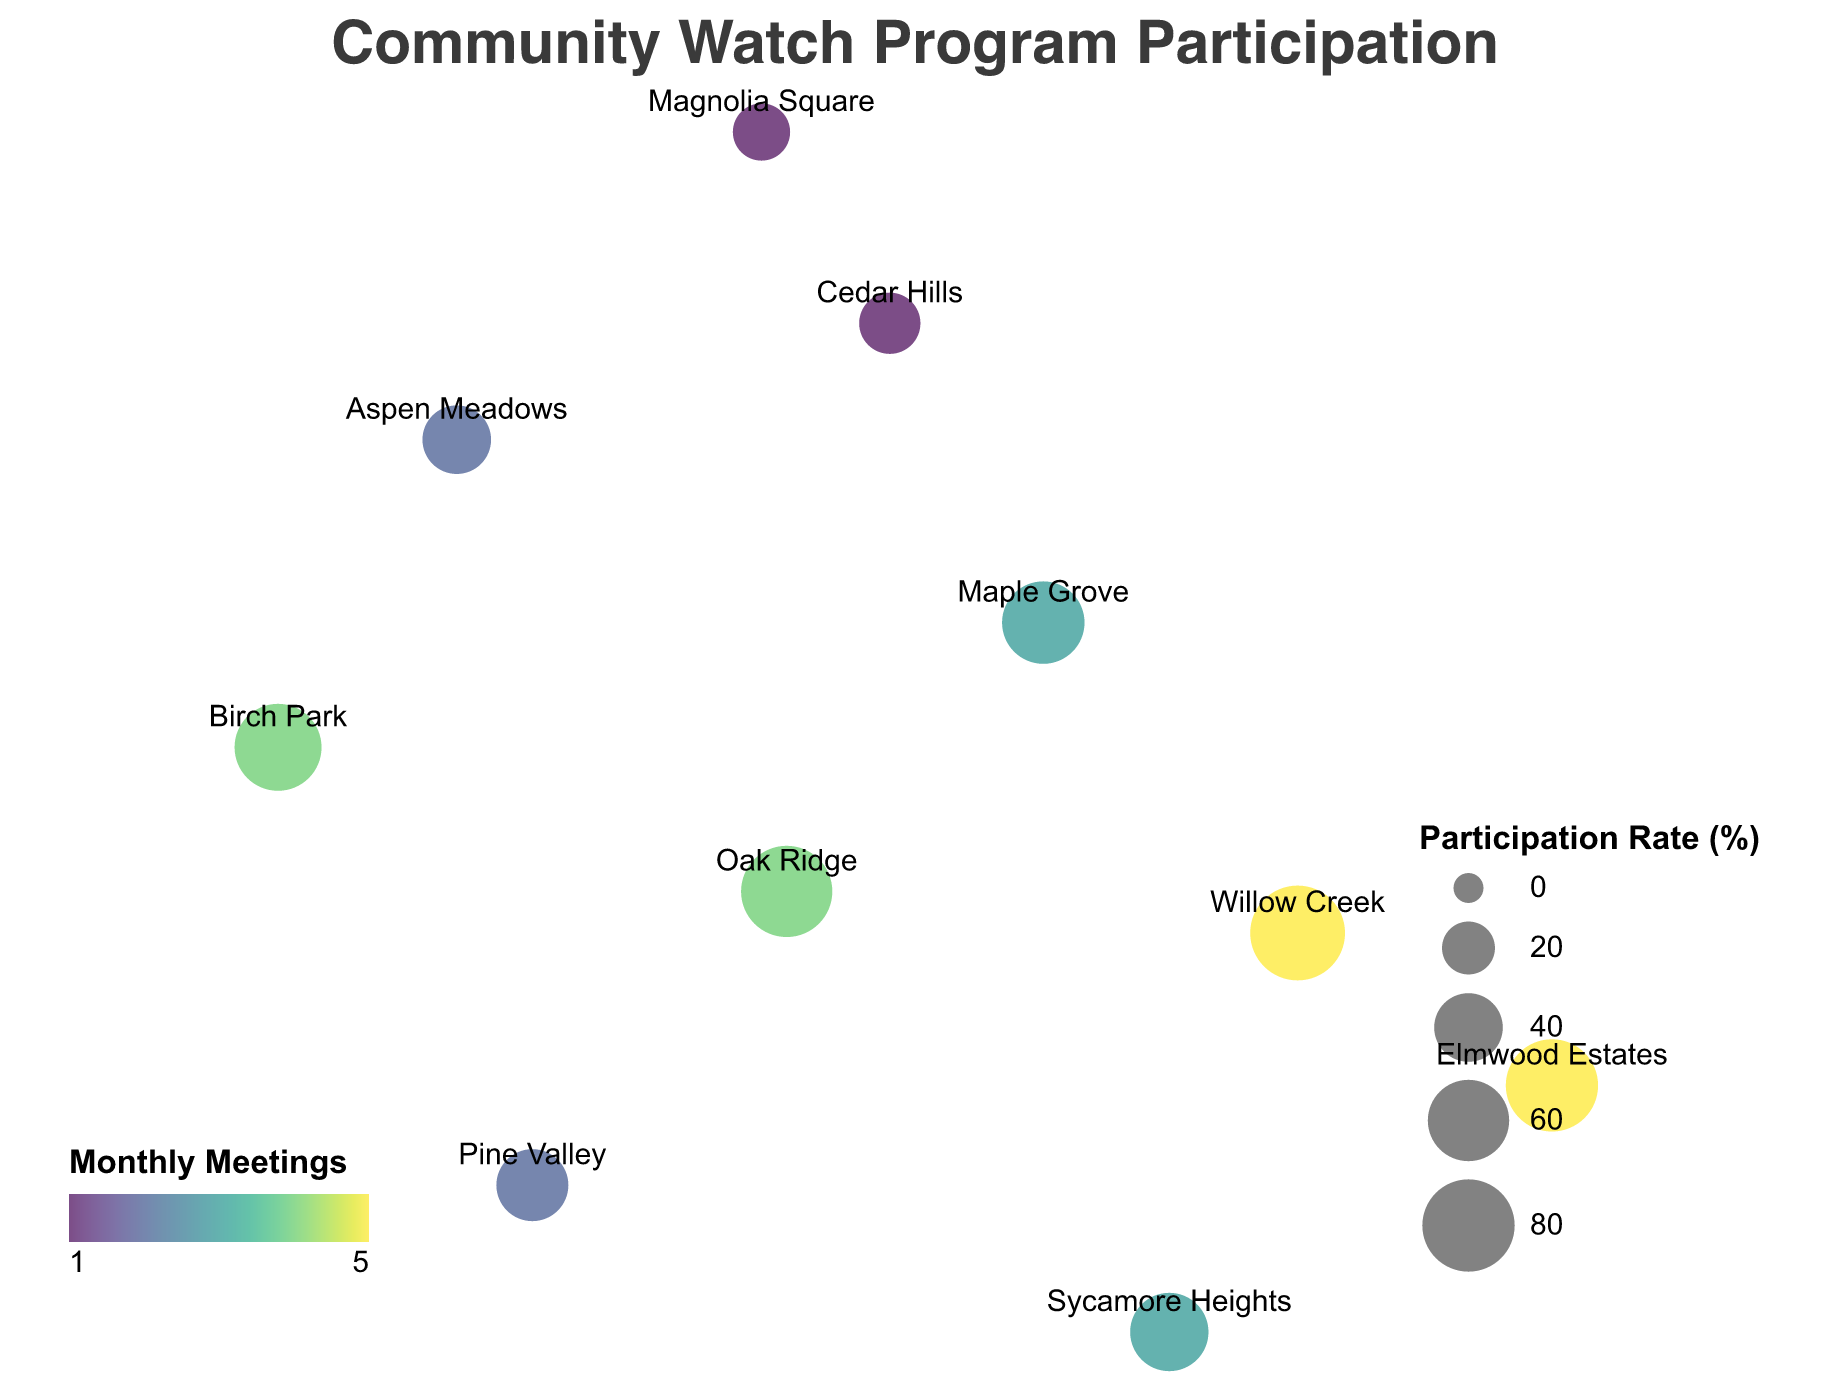What is the title of the geographic plot? The title is prominently displayed at the top of the plot. It states the main subject or theme of the visualization.
Answer: Community Watch Program Participation Which neighborhood has the highest participation rate? By observing the size of the circles (which corresponds to the participation rate), the neighborhood with the largest circle indicates the highest participation rate.
Answer: Willow Creek Which neighborhood has the lowest number of monthly meetings? The color of the circles represents the number of monthly meetings, with a specific color indicating the lowest value. Identifying the lightest or the least intense coloration reveals the neighborhood with the fewest monthly meetings.
Answer: Cedar Hills Compare the participation rates between Oak Ridge and Pine Valley. Which one is higher, and by how much? Check the size of the circles for Oak Ridge and Pine Valley, noting that larger circles represent higher participation rates. Subtract the participation rate of Pine Valley from Oak Ridge's.
Answer: Oak Ridge's rate is higher by 33% (78% - 45%) Which neighborhoods have both a high participation rate and a high number of monthly meetings? Look for large-sized circles (indicating high participation rates) that are colored with darker or more intense shades (indicating higher numbers of monthly meetings).
Answer: Willow Creek and Elmwood Estates What is the average number of monthly meetings across all neighborhoods? Sum the number of monthly meetings for all neighborhoods and divide by the total number of neighborhoods. (4 + 3 + 2 + 5 + 1 + 4 + 3 + 2 + 5 + 1 = 30; 30 / 10 = 3)
Answer: 3 Which neighborhood is located furthest to the north? Identify the neighborhood with the highest latitude value, as latitude increases going north.
Answer: Magnolia Square Describe the geographic spread in terms of longitude for the neighborhoods. By examining the longitudinal values, note the range covered by the neighborhoods: the most easterly and westerly points reveal the geographic spread.
Answer: From approximately -84.4567 (Elmwood Estates) to -84.5123 (Birch Park) How does the participation rate of Cedar Hills compare to Birch Park? Compare the sizes of the circles representing Cedar Hills and Birch Park; determine which circle is larger and calculate the difference in their participation rates.
Answer: Birch Park's rate is 40% higher (70% - 30%) Which neighborhood has the median participation rate? List the participation rates in ascending order and find the middle value. If there's an even number of data points, average the middle two participation rates. (25, 30, 40, 45, 55, 62, 70, 78, 80, 85; median is (55+62)/2=58.5%)
Answer: Between Sycamore Heights and Maple Grove 